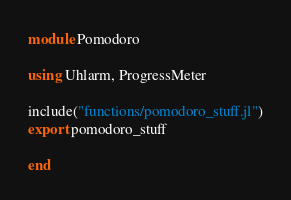Convert code to text. <code><loc_0><loc_0><loc_500><loc_500><_Julia_>module Pomodoro

using Uhlarm, ProgressMeter

include("functions/pomodoro_stuff.jl")
export pomodoro_stuff

end
</code> 